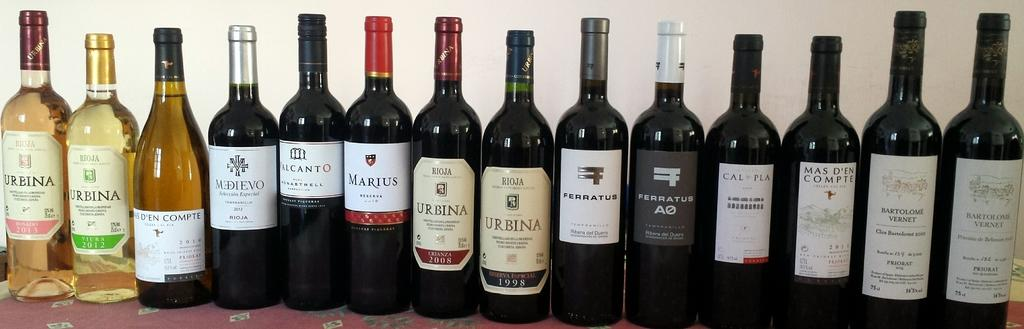<image>
Write a terse but informative summary of the picture. Several wine bottles are lined up and the one on the far right says "URBINA" on the label. 